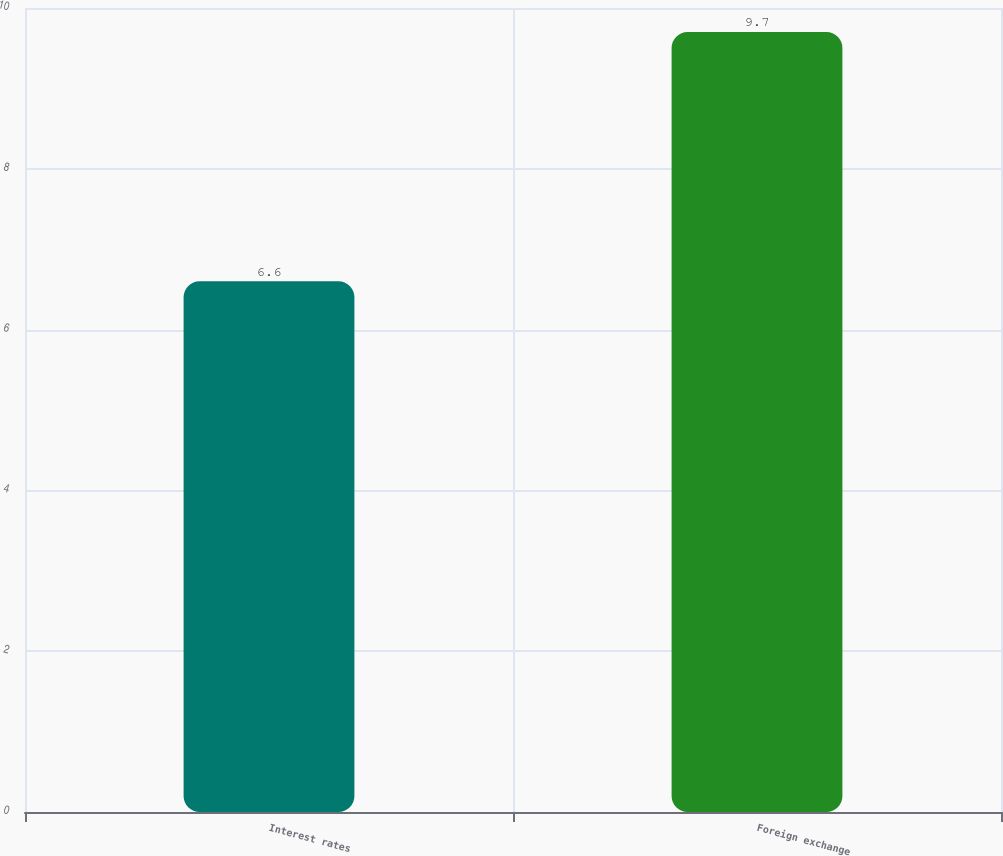Convert chart to OTSL. <chart><loc_0><loc_0><loc_500><loc_500><bar_chart><fcel>Interest rates<fcel>Foreign exchange<nl><fcel>6.6<fcel>9.7<nl></chart> 